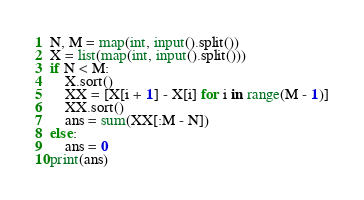<code> <loc_0><loc_0><loc_500><loc_500><_Python_>N, M = map(int, input().split())
X = list(map(int, input().split()))
if N < M:
    X.sort()
    XX = [X[i + 1] - X[i] for i in range(M - 1)]
    XX.sort()
    ans = sum(XX[:M - N])
else:
    ans = 0
print(ans)</code> 